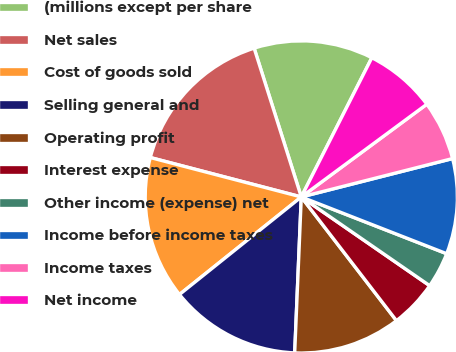<chart> <loc_0><loc_0><loc_500><loc_500><pie_chart><fcel>(millions except per share<fcel>Net sales<fcel>Cost of goods sold<fcel>Selling general and<fcel>Operating profit<fcel>Interest expense<fcel>Other income (expense) net<fcel>Income before income taxes<fcel>Income taxes<fcel>Net income<nl><fcel>12.35%<fcel>16.05%<fcel>14.81%<fcel>13.58%<fcel>11.11%<fcel>4.94%<fcel>3.7%<fcel>9.88%<fcel>6.17%<fcel>7.41%<nl></chart> 